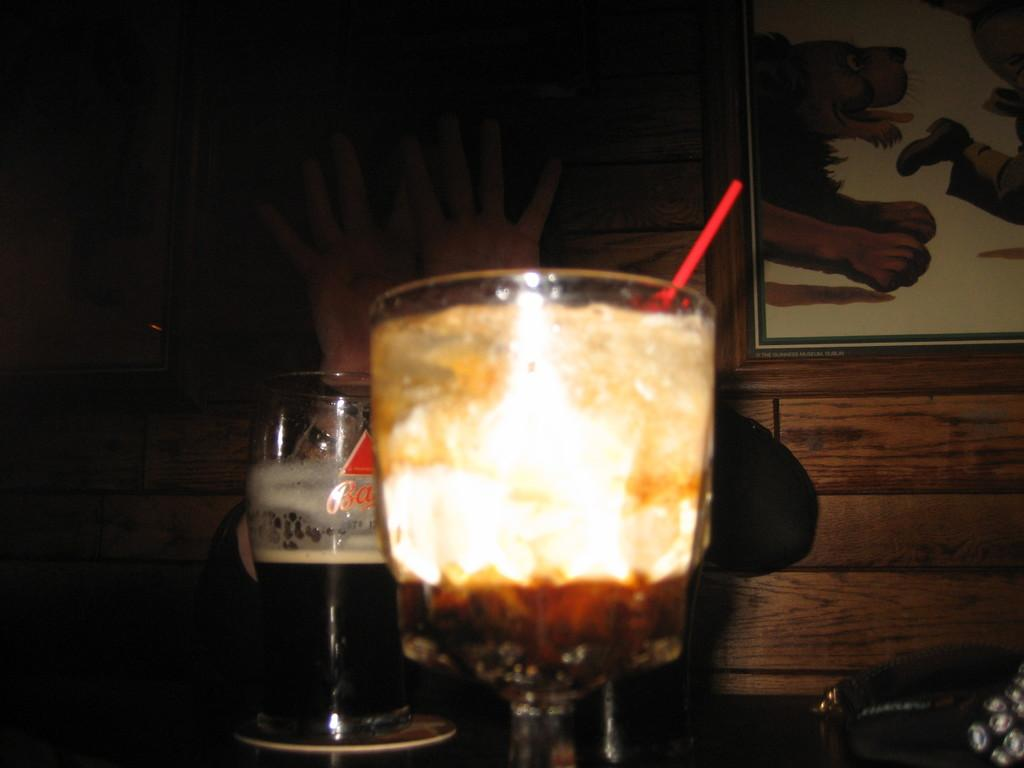What objects are on the platform in the image? There are glasses with a drink on a platform in the image. Whose hands are visible in the image? The hands of a person are visible in the image. How would you describe the overall lighting in the image? The background of the image is dark. What type of structure can be seen in the image? There is a wall in the image. What type of decorative items are present in the image? There are frames in the image. What type of blade is being used by the creator in the image? There is no creator or blade present in the image. How does the maid interact with the glasses in the image? There is no maid present in the image, and therefore no interaction with the glasses can be observed. 